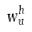<formula> <loc_0><loc_0><loc_500><loc_500>w _ { u } ^ { h }</formula> 